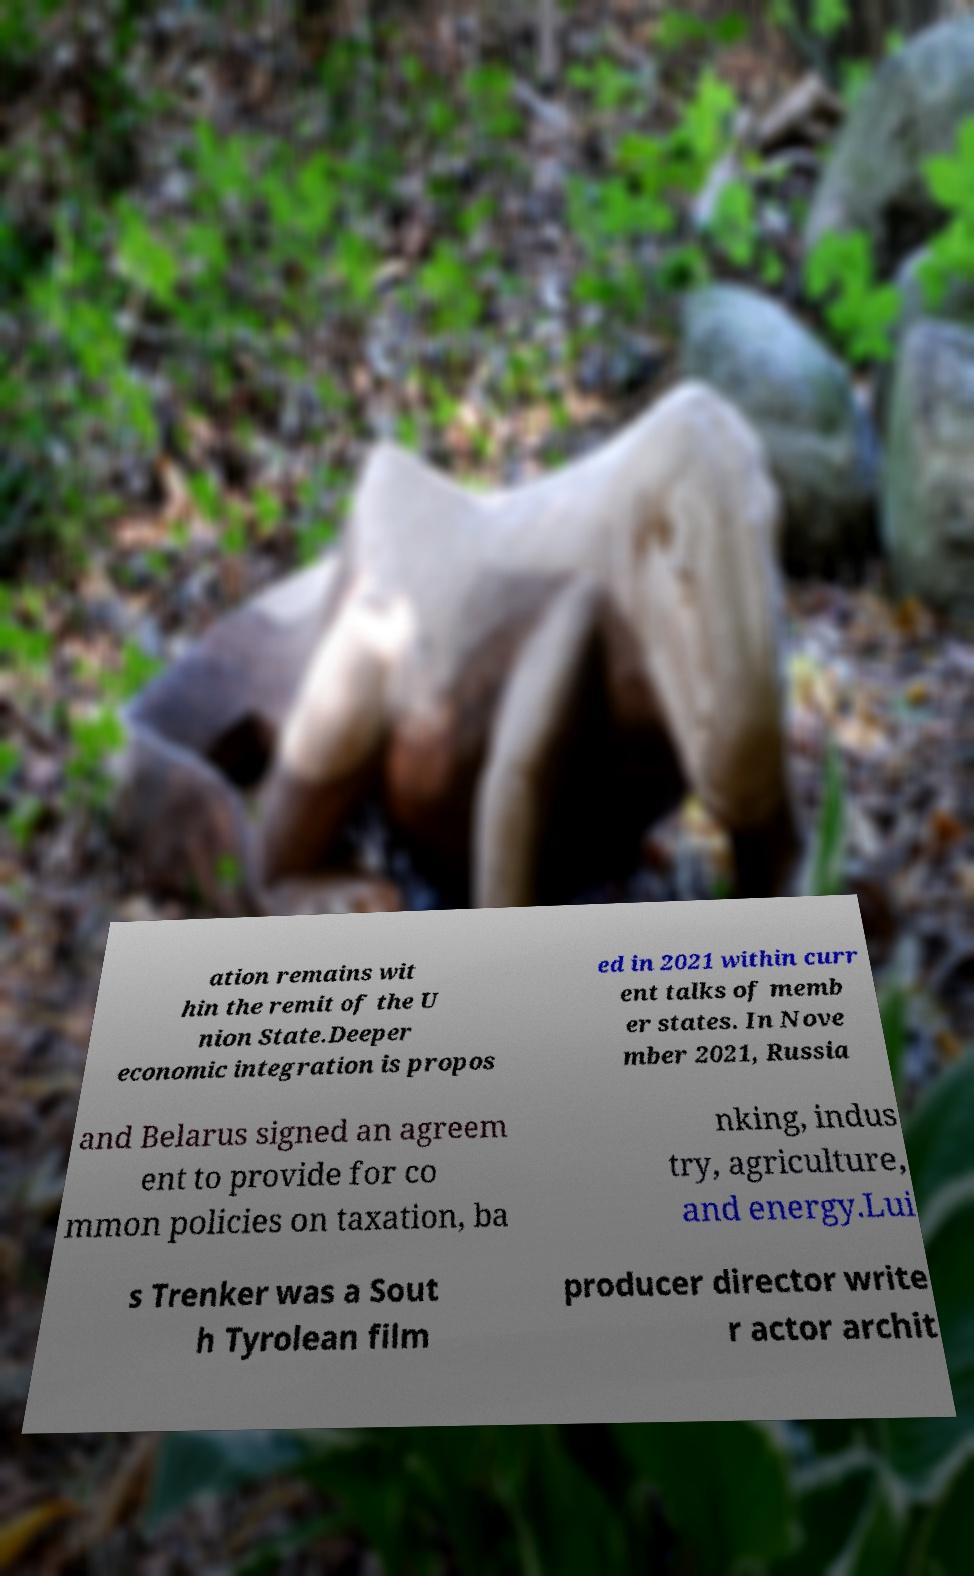Could you extract and type out the text from this image? ation remains wit hin the remit of the U nion State.Deeper economic integration is propos ed in 2021 within curr ent talks of memb er states. In Nove mber 2021, Russia and Belarus signed an agreem ent to provide for co mmon policies on taxation, ba nking, indus try, agriculture, and energy.Lui s Trenker was a Sout h Tyrolean film producer director write r actor archit 